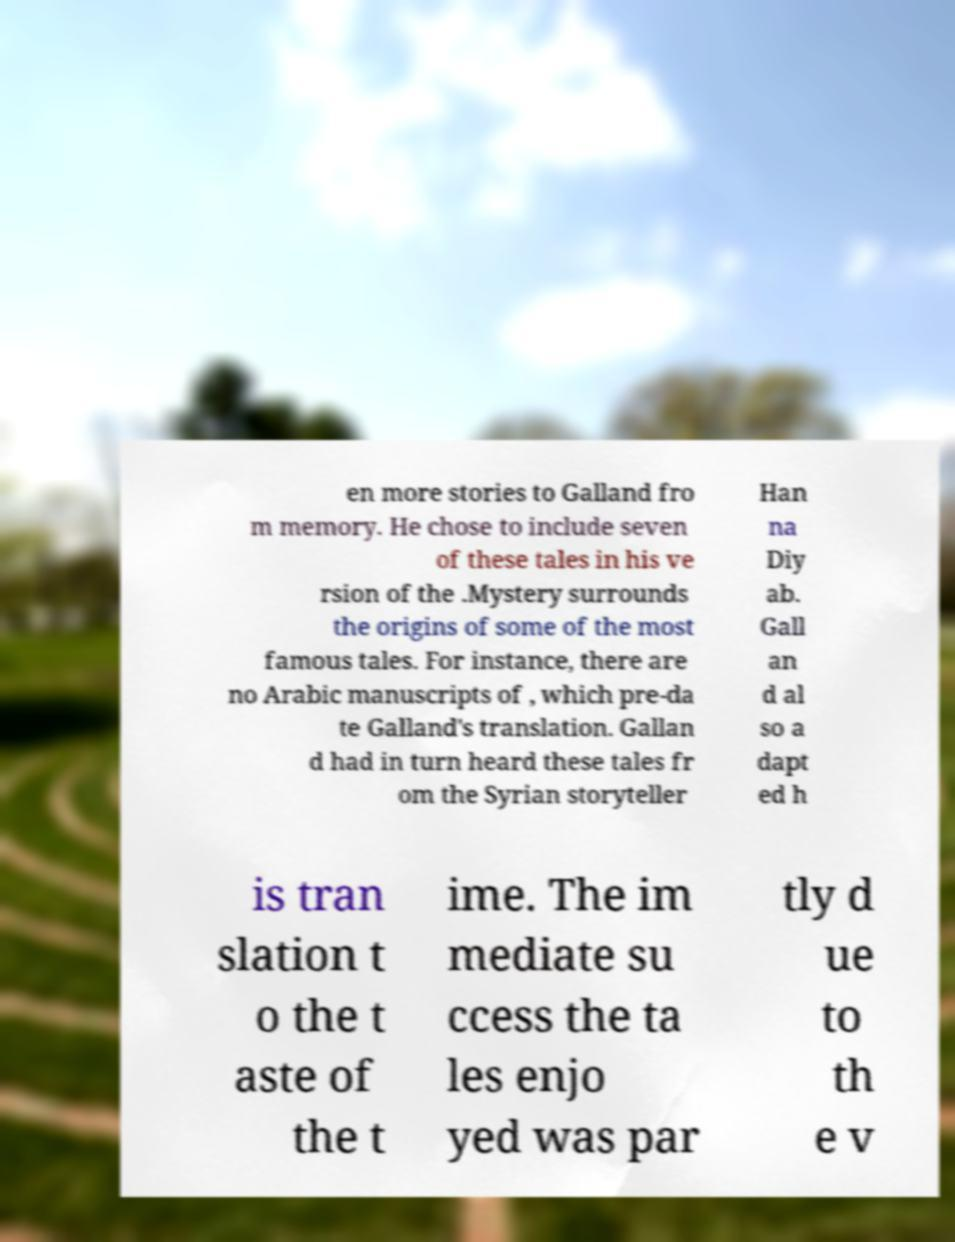There's text embedded in this image that I need extracted. Can you transcribe it verbatim? en more stories to Galland fro m memory. He chose to include seven of these tales in his ve rsion of the .Mystery surrounds the origins of some of the most famous tales. For instance, there are no Arabic manuscripts of , which pre-da te Galland's translation. Gallan d had in turn heard these tales fr om the Syrian storyteller Han na Diy ab. Gall an d al so a dapt ed h is tran slation t o the t aste of the t ime. The im mediate su ccess the ta les enjo yed was par tly d ue to th e v 